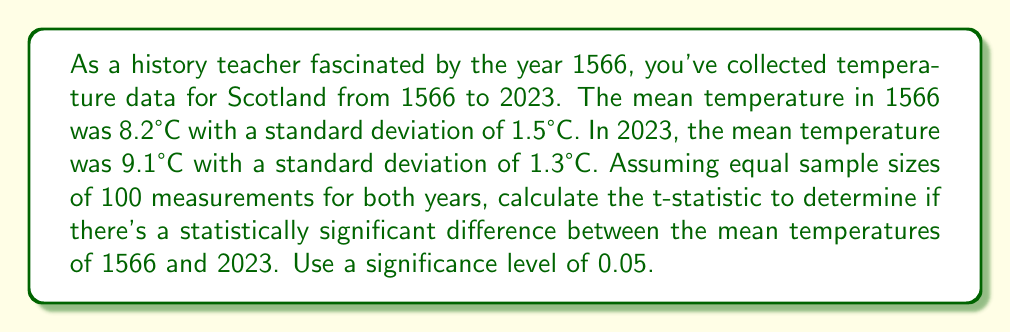Help me with this question. To determine if there's a statistically significant difference between the mean temperatures, we'll use a two-sample t-test. The steps are as follows:

1. Calculate the pooled standard deviation:
   $$s_p = \sqrt{\frac{(n_1 - 1)s_1^2 + (n_2 - 1)s_2^2}{n_1 + n_2 - 2}}$$
   Where $n_1 = n_2 = 100$, $s_1 = 1.5$, and $s_2 = 1.3$
   
   $$s_p = \sqrt{\frac{(100 - 1)1.5^2 + (100 - 1)1.3^2}{100 + 100 - 2}} = \sqrt{\frac{222.75 + 166.53}{198}} = 1.4018$$

2. Calculate the t-statistic:
   $$t = \frac{\bar{x}_1 - \bar{x}_2}{s_p\sqrt{\frac{2}{n}}}$$
   Where $\bar{x}_1 = 8.2$, $\bar{x}_2 = 9.1$, and $n = 100$
   
   $$t = \frac{8.2 - 9.1}{1.4018\sqrt{\frac{2}{100}}} = \frac{-0.9}{0.1982} = -4.5408$$

3. Determine the critical t-value:
   For a two-tailed test with $\alpha = 0.05$ and $df = n_1 + n_2 - 2 = 198$, the critical t-value is approximately $\pm 1.972$.

4. Compare the calculated t-statistic to the critical value:
   $|-4.5408| > 1.972$, so we reject the null hypothesis.

Therefore, there is a statistically significant difference between the mean temperatures of 1566 and 2023.
Answer: $t = -4.5408$ 